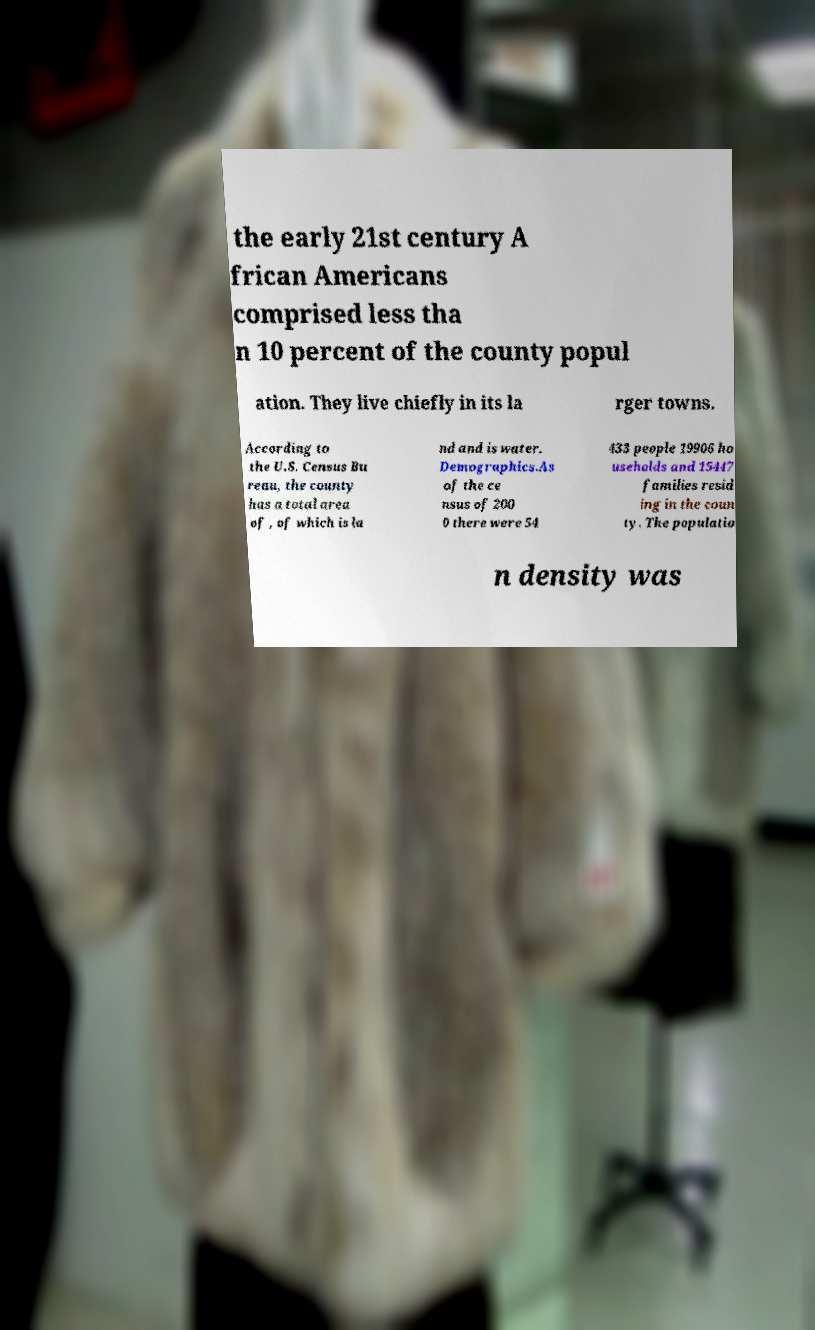There's text embedded in this image that I need extracted. Can you transcribe it verbatim? the early 21st century A frican Americans comprised less tha n 10 percent of the county popul ation. They live chiefly in its la rger towns. According to the U.S. Census Bu reau, the county has a total area of , of which is la nd and is water. Demographics.As of the ce nsus of 200 0 there were 54 433 people 19906 ho useholds and 15447 families resid ing in the coun ty. The populatio n density was 